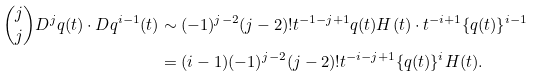<formula> <loc_0><loc_0><loc_500><loc_500>\binom { j } { j } D ^ { j } q ( t ) \cdot D q ^ { i - 1 } ( t ) & \sim ( - 1 ) ^ { j - 2 } ( j - 2 ) ! t ^ { - 1 - j + 1 } q ( t ) H ( t ) \cdot t ^ { - i + 1 } \{ q ( t ) \} ^ { i - 1 } \\ & = ( i - 1 ) ( - 1 ) ^ { j - 2 } ( j - 2 ) ! t ^ { - i - j + 1 } \{ q ( t ) \} ^ { i } H ( t ) .</formula> 